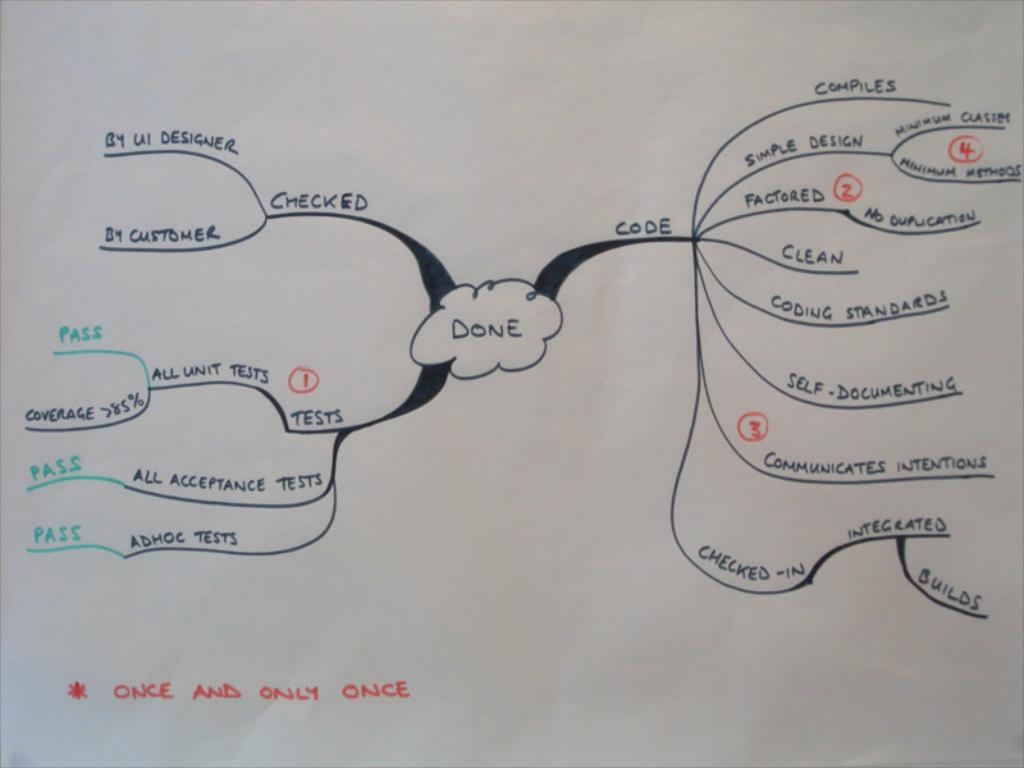What happens when you get to the center of the flow chart?
Keep it short and to the point. Done. What is in the middle of the paper?
Ensure brevity in your answer.  Done. 